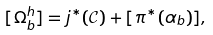<formula> <loc_0><loc_0><loc_500><loc_500>[ \Omega ^ { h } _ { b } ] = j ^ { * } ( \mathcal { C } ) + [ \pi ^ { * } ( \alpha _ { b } ) ] ,</formula> 